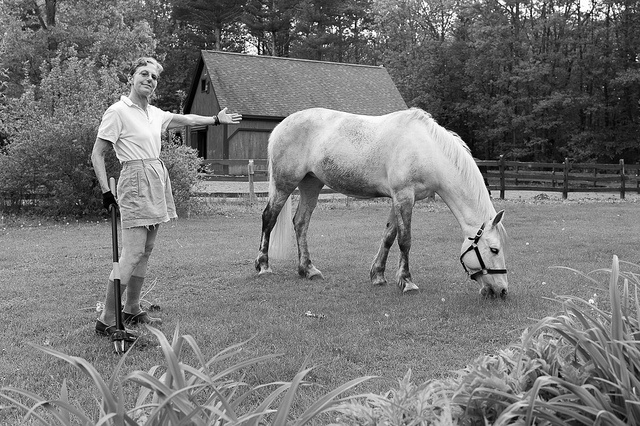Describe the objects in this image and their specific colors. I can see horse in gray, lightgray, darkgray, and black tones and people in gray, darkgray, gainsboro, and black tones in this image. 